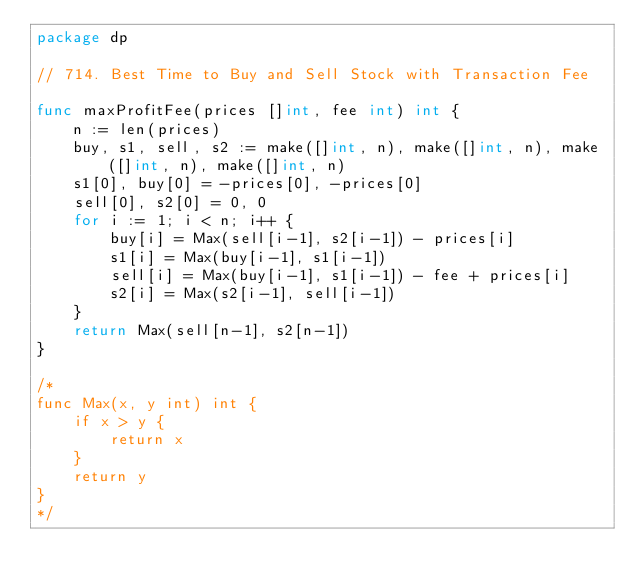<code> <loc_0><loc_0><loc_500><loc_500><_Go_>package dp

// 714. Best Time to Buy and Sell Stock with Transaction Fee

func maxProfitFee(prices []int, fee int) int {
	n := len(prices)
	buy, s1, sell, s2 := make([]int, n), make([]int, n), make([]int, n), make([]int, n)
	s1[0], buy[0] = -prices[0], -prices[0]
	sell[0], s2[0] = 0, 0
	for i := 1; i < n; i++ {
		buy[i] = Max(sell[i-1], s2[i-1]) - prices[i]
		s1[i] = Max(buy[i-1], s1[i-1])
		sell[i] = Max(buy[i-1], s1[i-1]) - fee + prices[i]
		s2[i] = Max(s2[i-1], sell[i-1])
	}
	return Max(sell[n-1], s2[n-1])
}

/*
func Max(x, y int) int {
	if x > y {
		return x
	}
	return y
}
*/
</code> 